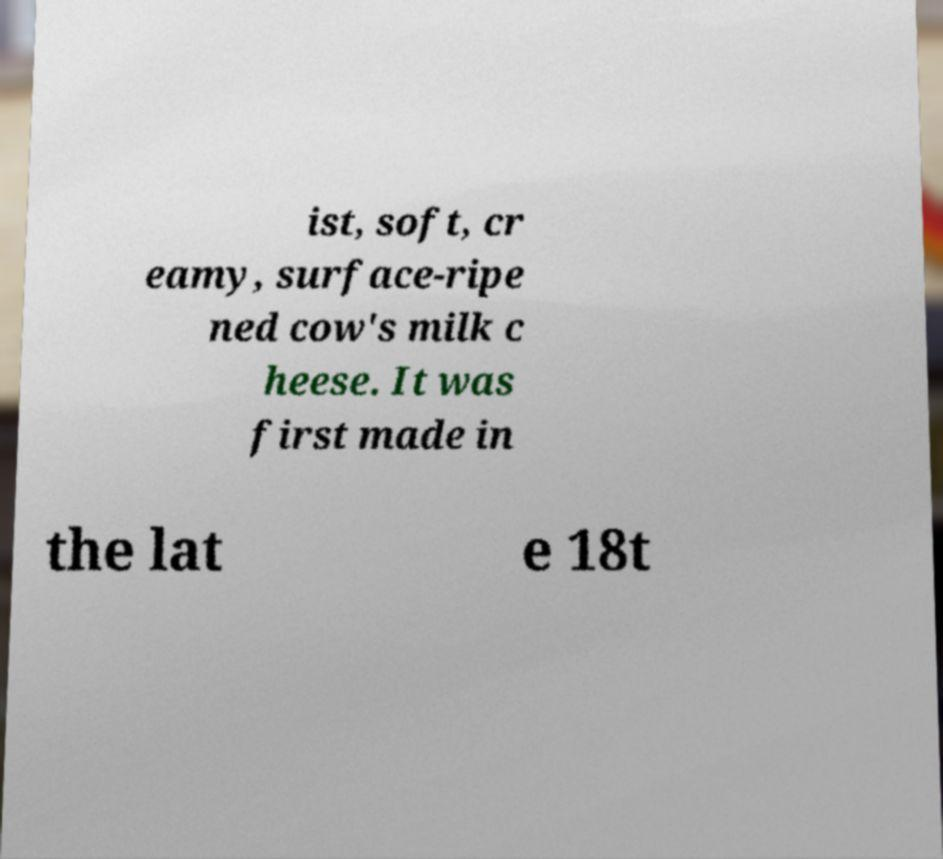Please read and relay the text visible in this image. What does it say? ist, soft, cr eamy, surface-ripe ned cow's milk c heese. It was first made in the lat e 18t 